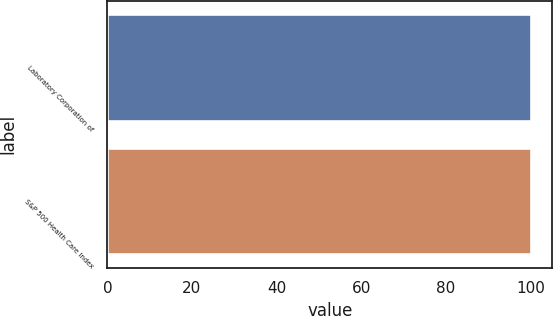Convert chart. <chart><loc_0><loc_0><loc_500><loc_500><bar_chart><fcel>Laboratory Corporation of<fcel>S&P 500 Health Care Index<nl><fcel>100<fcel>100.1<nl></chart> 